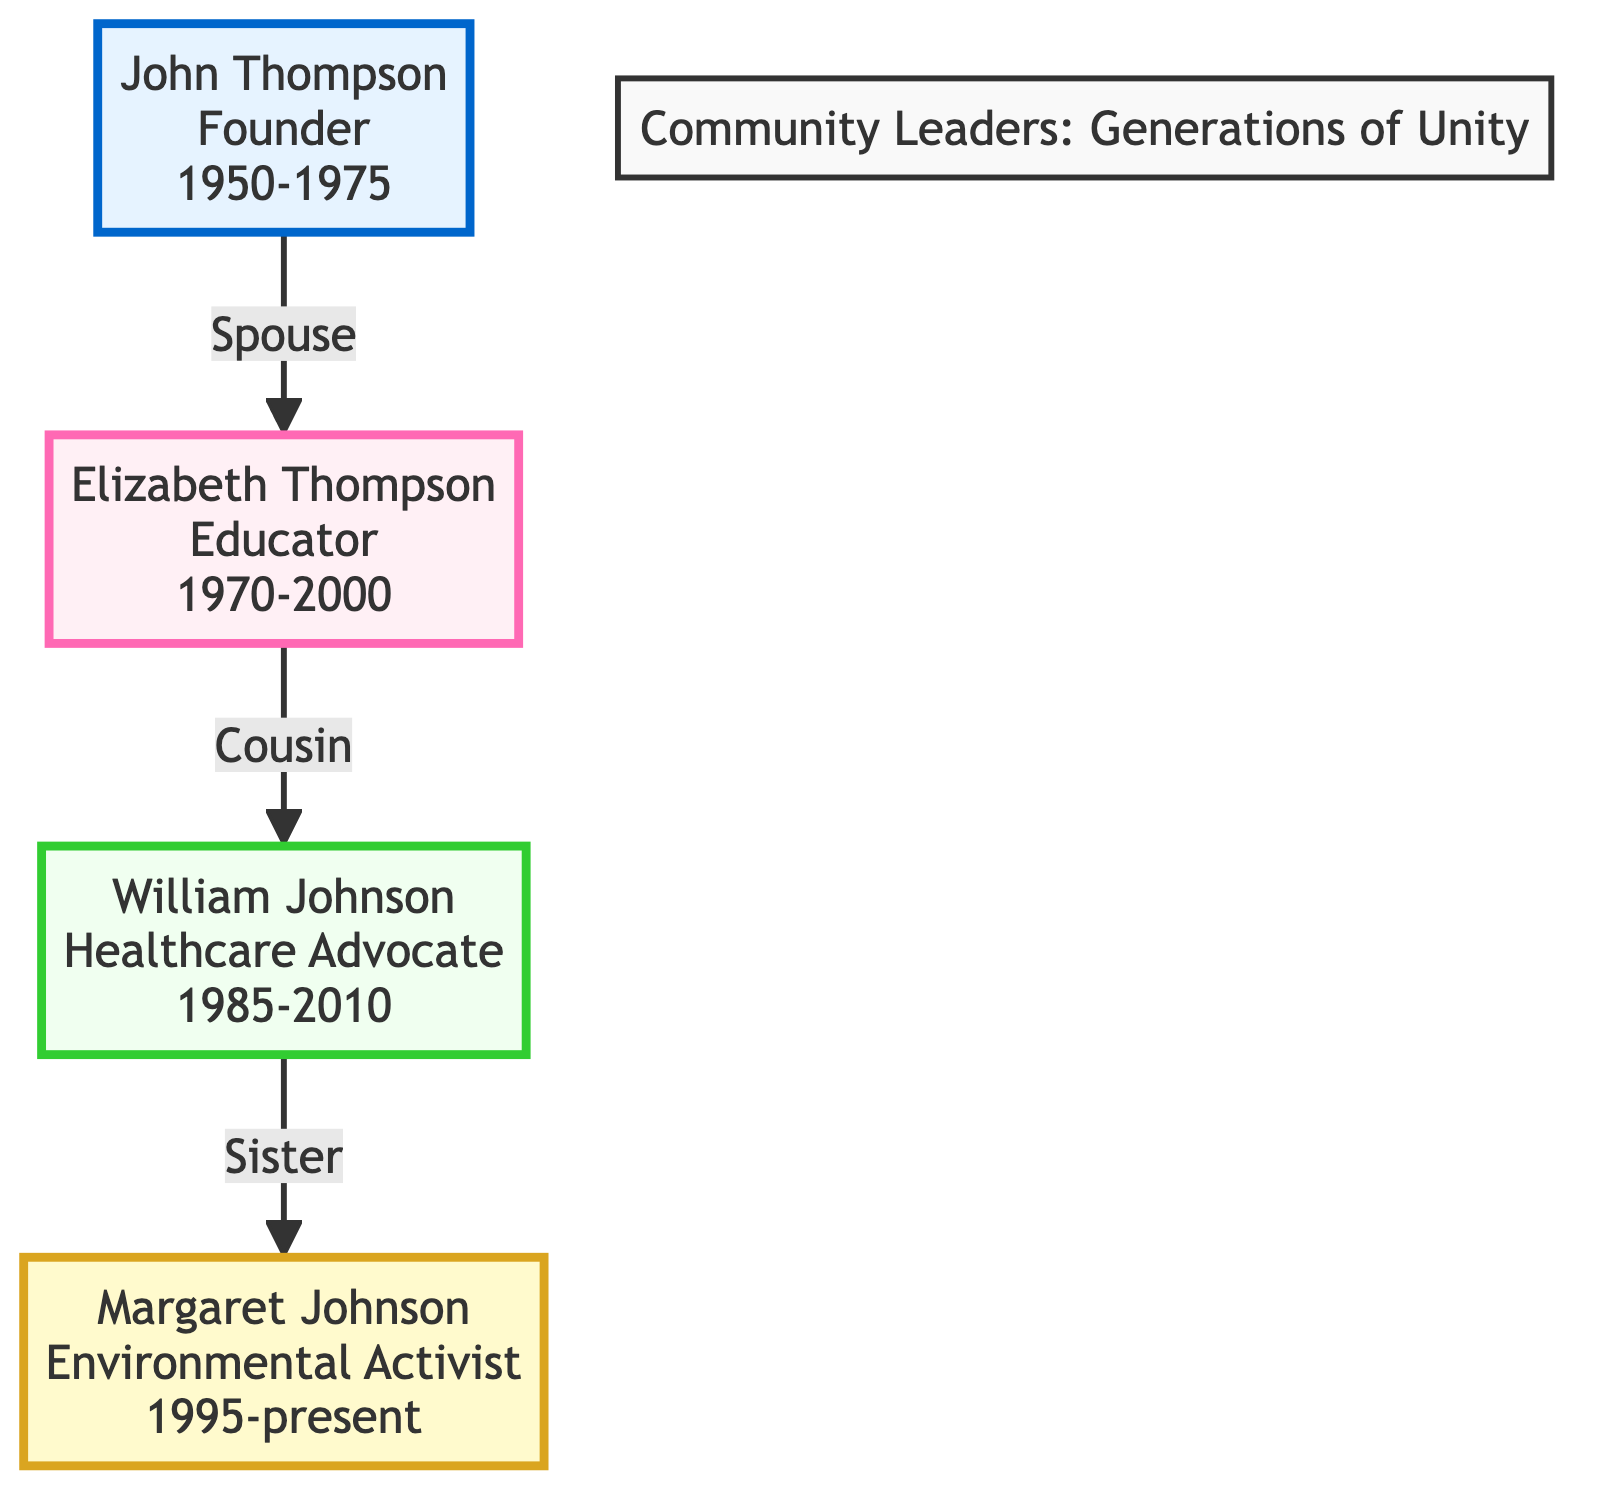What is the role of John Thompson? The diagram explicitly lists John Thompson's role as "Founder" within the community leaders' family tree.
Answer: Founder How many years did Elizabeth Thompson actively contribute to the community? By reading the diagram, we notice that Elizabeth Thompson's years active are indicated as "1970-2000," which represents a total of 30 years.
Answer: 30 What established connection exists between John Thompson and Elizabeth Thompson? The diagram highlights that John Thompson and Elizabeth Thompson have a relationship marked as "Spouse," indicating their marital connection.
Answer: Spouse Which leader initiated free community health clinics? The diagram shows that William Johnson is credited with initiating free community health clinics, as documented in his contributions.
Answer: William Johnson What is the primary focus of the community school opened by Elizabeth Thompson? According to the diagram, Elizabeth Thompson opened a community school with a focus on "unity and cooperation," as stated in her contributions.
Answer: unity and cooperation How is Margaret Johnson related to William Johnson? The diagram indicates that William Johnson and Margaret Johnson are connected by the relationship labeled "Sister," meaning they are siblings.
Answer: Sister How many community leaders are represented in the family tree? The diagram consists of a total of four community leaders, as evidenced by the four nodes present within the family tree.
Answer: 4 Which community leader is associated with environmental activism? Looking at the contributions listed in the diagram, it is clear that Margaret Johnson is the one associated with environmental activism as denoted by her role.
Answer: Margaret Johnson What type of campaigns did Margaret Johnson lead? The diagram states that Margaret Johnson led campaigns for "sustainable farming," clearly reflecting her environmental focus in her contributions.
Answer: sustainable farming 